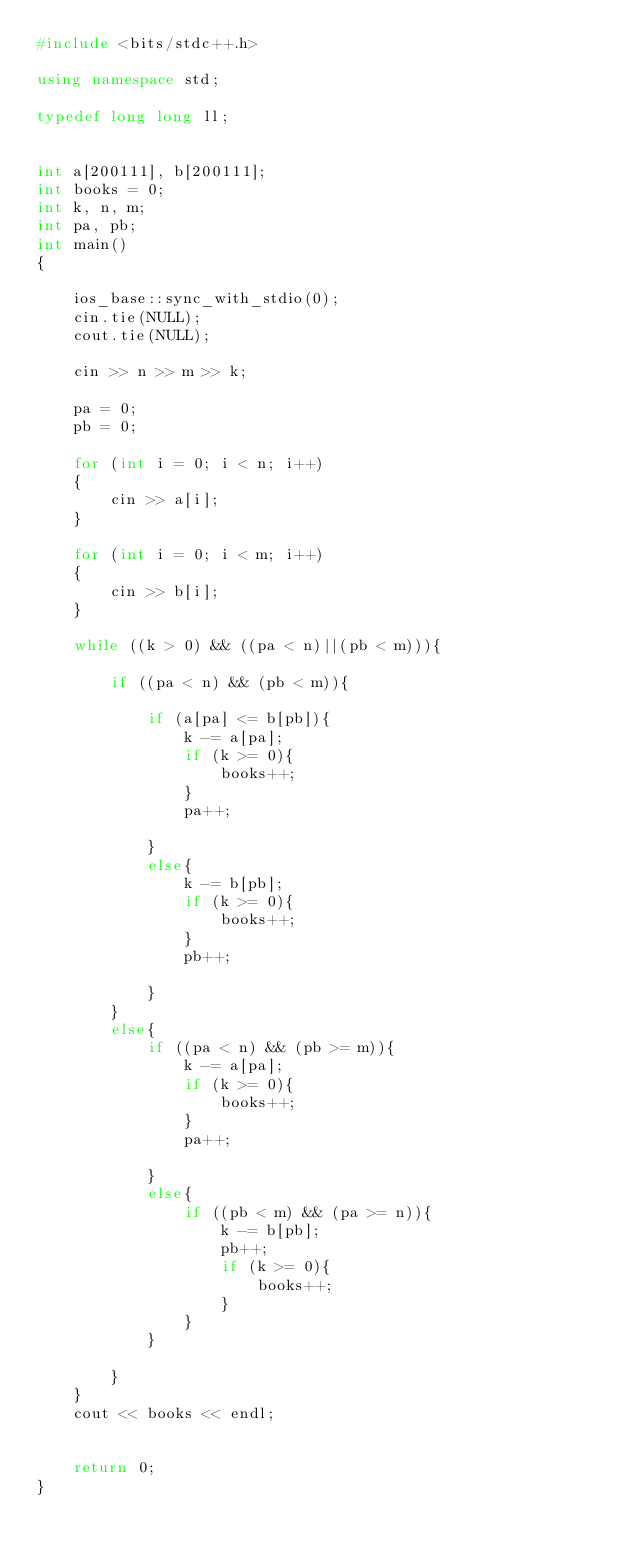<code> <loc_0><loc_0><loc_500><loc_500><_C++_>#include <bits/stdc++.h>

using namespace std;

typedef long long ll;


int a[200111], b[200111];
int books = 0;
int k, n, m;
int pa, pb;
int main()
{
    
    ios_base::sync_with_stdio(0);
    cin.tie(NULL);
    cout.tie(NULL);

    cin >> n >> m >> k;

    pa = 0;
    pb = 0;

    for (int i = 0; i < n; i++)
    {
        cin >> a[i];
    }

    for (int i = 0; i < m; i++)
    {
        cin >> b[i];
    }

    while ((k > 0) && ((pa < n)||(pb < m))){

        if ((pa < n) && (pb < m)){
           
            if (a[pa] <= b[pb]){
                k -= a[pa];
                if (k >= 0){
                    books++;
                }
                pa++;
                
            }
            else{
                k -= b[pb];
                if (k >= 0){
                    books++;
                }
                pb++;
                
            }
        }
        else{
            if ((pa < n) && (pb >= m)){
                k -= a[pa];
                if (k >= 0){
                    books++;
                }
                pa++;
                
            }
            else{
                if ((pb < m) && (pa >= n)){
                    k -= b[pb];
                    pb++;
                    if (k >= 0){
                        books++;
                    }
                } 
            }

        }
    }
    cout << books << endl;

 
    return 0;
}
</code> 